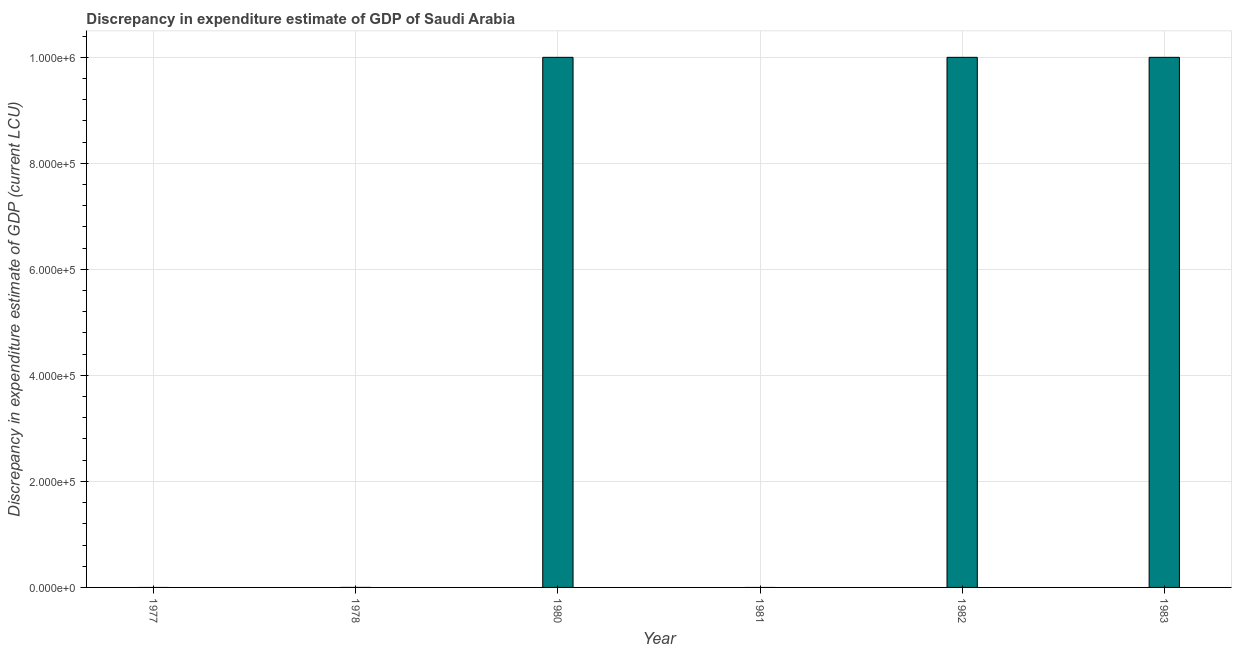Does the graph contain any zero values?
Offer a terse response. Yes. What is the title of the graph?
Make the answer very short. Discrepancy in expenditure estimate of GDP of Saudi Arabia. What is the label or title of the X-axis?
Make the answer very short. Year. What is the label or title of the Y-axis?
Provide a short and direct response. Discrepancy in expenditure estimate of GDP (current LCU). What is the discrepancy in expenditure estimate of gdp in 1981?
Provide a succinct answer. 0. Across all years, what is the maximum discrepancy in expenditure estimate of gdp?
Make the answer very short. 1.00e+06. In which year was the discrepancy in expenditure estimate of gdp maximum?
Offer a very short reply. 1983. What is the sum of the discrepancy in expenditure estimate of gdp?
Provide a succinct answer. 3.00e+06. What is the difference between the discrepancy in expenditure estimate of gdp in 1980 and 1983?
Give a very brief answer. -0. What is the average discrepancy in expenditure estimate of gdp per year?
Provide a succinct answer. 5.00e+05. What is the median discrepancy in expenditure estimate of gdp?
Ensure brevity in your answer.  5.00e+05. In how many years, is the discrepancy in expenditure estimate of gdp greater than 160000 LCU?
Offer a terse response. 3. Is the discrepancy in expenditure estimate of gdp in 1980 less than that in 1983?
Provide a succinct answer. Yes. Is the difference between the discrepancy in expenditure estimate of gdp in 1980 and 1983 greater than the difference between any two years?
Ensure brevity in your answer.  No. What is the difference between the highest and the lowest discrepancy in expenditure estimate of gdp?
Give a very brief answer. 1.00e+06. Are all the bars in the graph horizontal?
Provide a short and direct response. No. What is the Discrepancy in expenditure estimate of GDP (current LCU) of 1977?
Ensure brevity in your answer.  0. What is the Discrepancy in expenditure estimate of GDP (current LCU) of 1978?
Your answer should be compact. 1.5e-5. What is the Discrepancy in expenditure estimate of GDP (current LCU) of 1981?
Give a very brief answer. 0. What is the Discrepancy in expenditure estimate of GDP (current LCU) of 1982?
Offer a terse response. 1.00e+06. What is the Discrepancy in expenditure estimate of GDP (current LCU) in 1983?
Give a very brief answer. 1.00e+06. What is the difference between the Discrepancy in expenditure estimate of GDP (current LCU) in 1978 and 1980?
Your response must be concise. -1.00e+06. What is the difference between the Discrepancy in expenditure estimate of GDP (current LCU) in 1978 and 1982?
Make the answer very short. -1.00e+06. What is the difference between the Discrepancy in expenditure estimate of GDP (current LCU) in 1978 and 1983?
Give a very brief answer. -1.00e+06. What is the difference between the Discrepancy in expenditure estimate of GDP (current LCU) in 1980 and 1983?
Provide a short and direct response. -3e-5. What is the difference between the Discrepancy in expenditure estimate of GDP (current LCU) in 1982 and 1983?
Offer a terse response. -3e-5. What is the ratio of the Discrepancy in expenditure estimate of GDP (current LCU) in 1978 to that in 1980?
Ensure brevity in your answer.  0. What is the ratio of the Discrepancy in expenditure estimate of GDP (current LCU) in 1978 to that in 1982?
Provide a short and direct response. 0. 